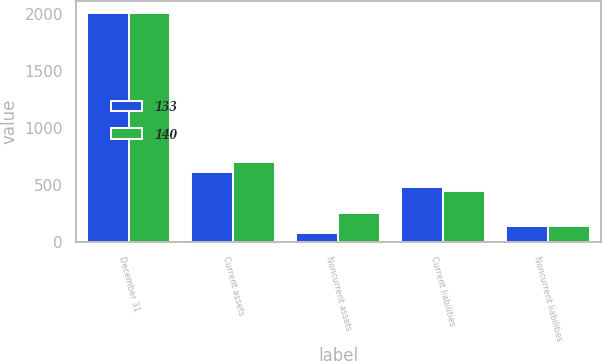Convert chart. <chart><loc_0><loc_0><loc_500><loc_500><stacked_bar_chart><ecel><fcel>December 31<fcel>Current assets<fcel>Noncurrent assets<fcel>Current liabilities<fcel>Noncurrent liabilities<nl><fcel>133<fcel>2011<fcel>614<fcel>75<fcel>478<fcel>140<nl><fcel>140<fcel>2010<fcel>699<fcel>254<fcel>442<fcel>133<nl></chart> 